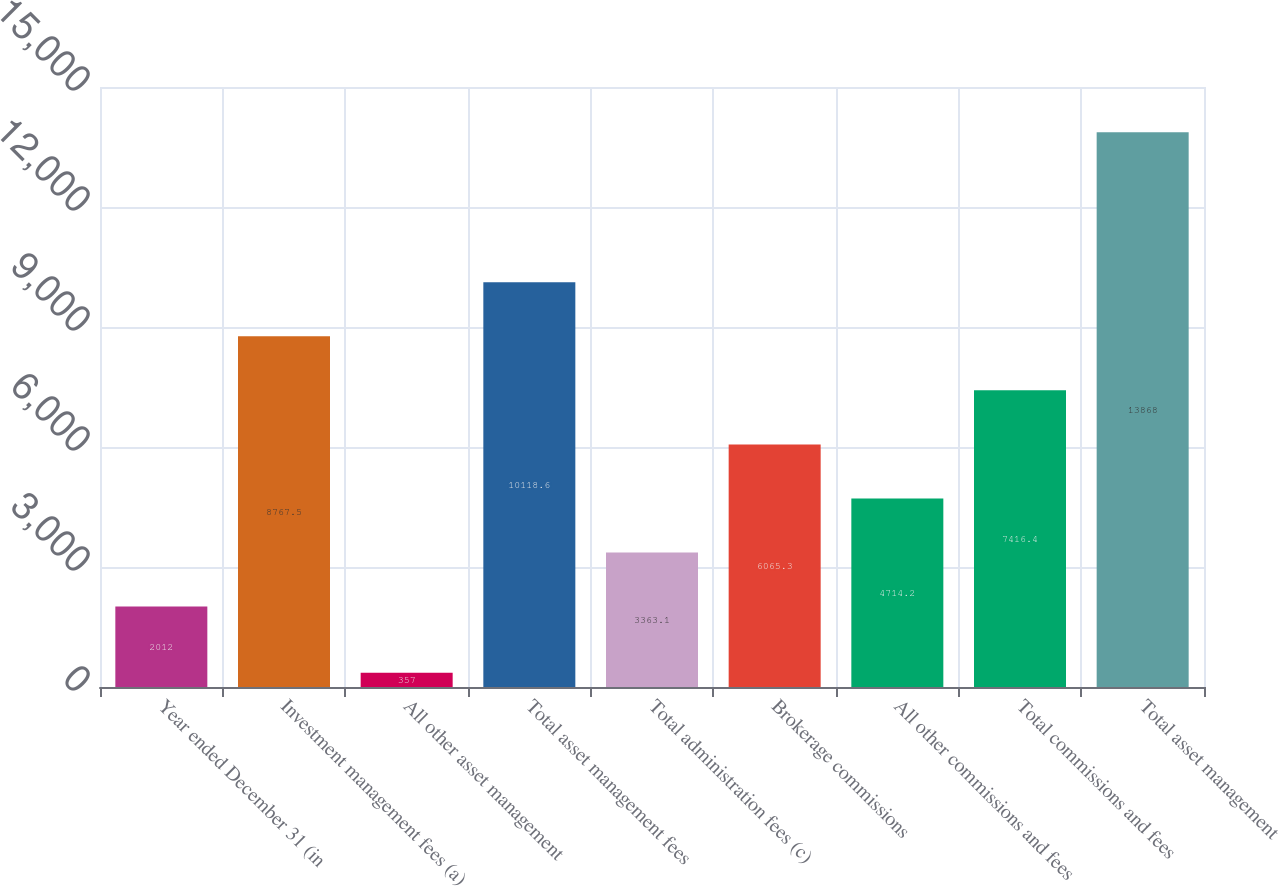Convert chart to OTSL. <chart><loc_0><loc_0><loc_500><loc_500><bar_chart><fcel>Year ended December 31 (in<fcel>Investment management fees (a)<fcel>All other asset management<fcel>Total asset management fees<fcel>Total administration fees (c)<fcel>Brokerage commissions<fcel>All other commissions and fees<fcel>Total commissions and fees<fcel>Total asset management<nl><fcel>2012<fcel>8767.5<fcel>357<fcel>10118.6<fcel>3363.1<fcel>6065.3<fcel>4714.2<fcel>7416.4<fcel>13868<nl></chart> 